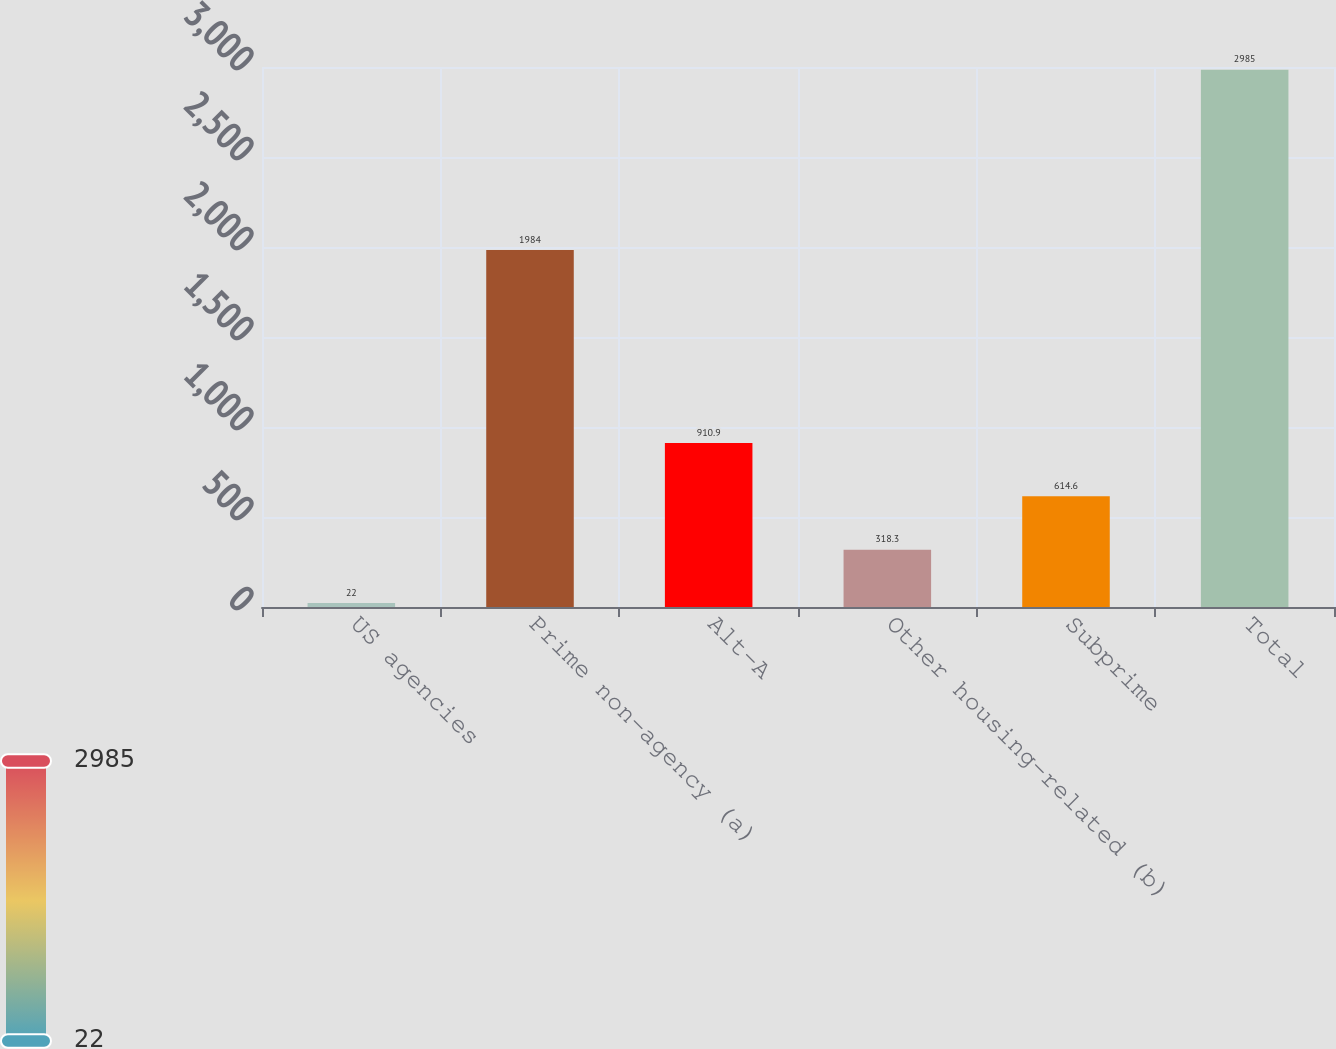<chart> <loc_0><loc_0><loc_500><loc_500><bar_chart><fcel>US agencies<fcel>Prime non-agency (a)<fcel>Alt-A<fcel>Other housing-related (b)<fcel>Subprime<fcel>Total<nl><fcel>22<fcel>1984<fcel>910.9<fcel>318.3<fcel>614.6<fcel>2985<nl></chart> 